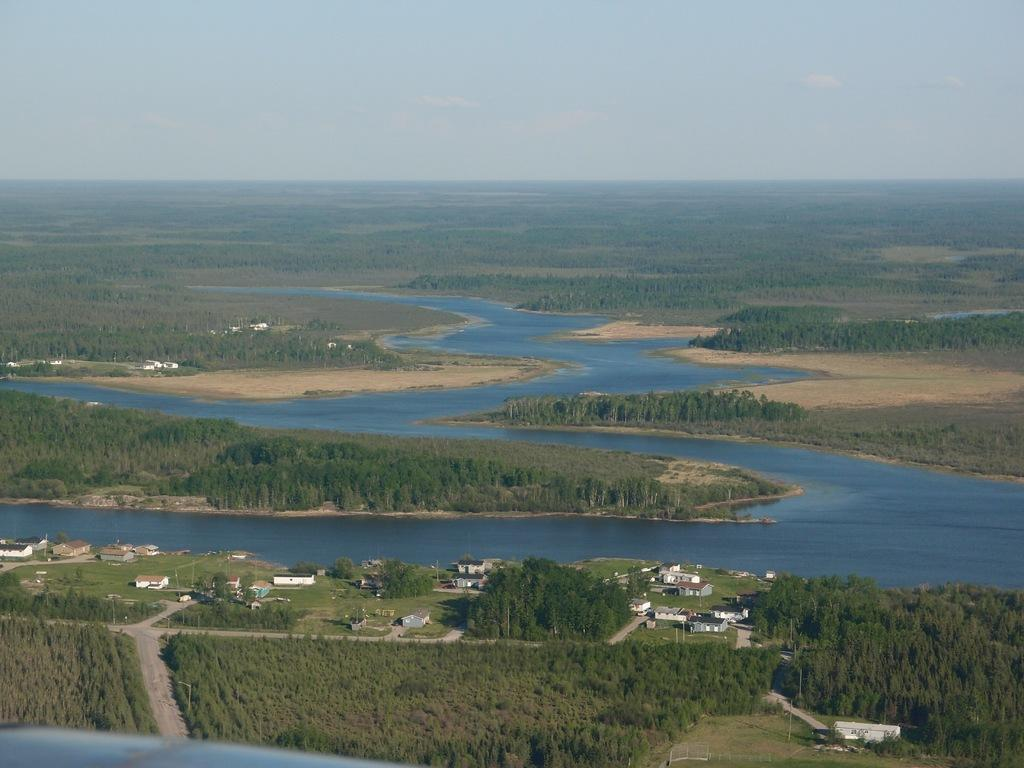What type of structures can be seen in the image? There are buildings in the image. What natural elements are present in the image? There are trees and water visible in the image. What man-made objects can be seen in the image? There are poles in the image. What is visible in the background of the image? The sky is visible in the image, and clouds are present in the sky. What type of voice can be heard coming from the crate in the image? There is no crate present in the image, and therefore no voice can be heard coming from it. 